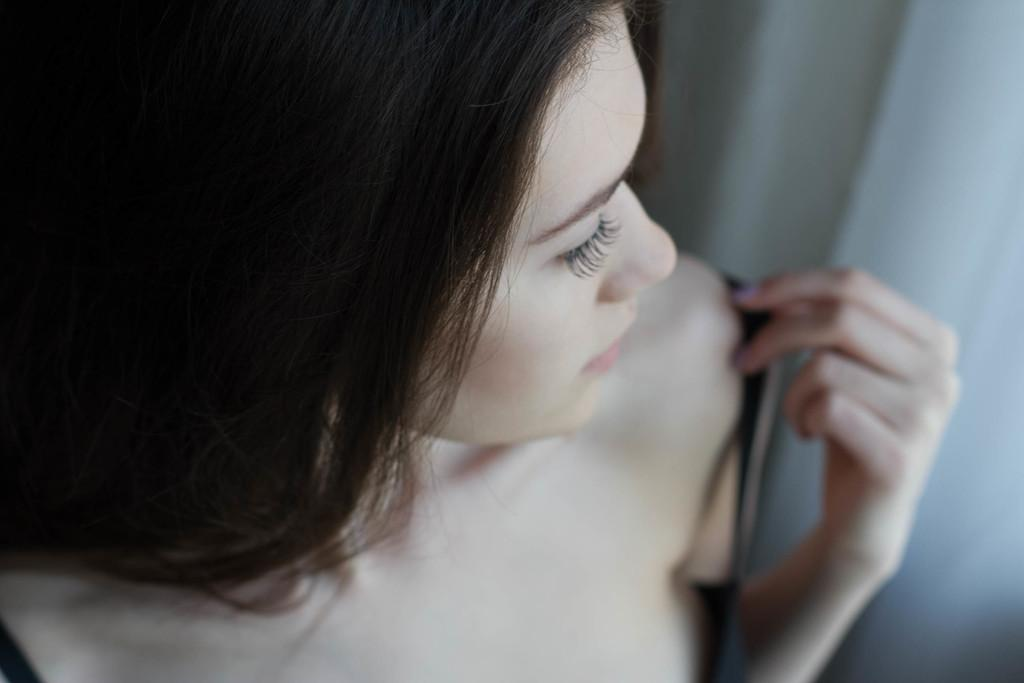Who is present in the image? There is a girl in the image. What can be seen on the right side of the image? There is a white-colored curtain on the right side of the image. What type of pancake is being prepared by the girl in the image? There is no pancake or indication of food preparation in the image. 